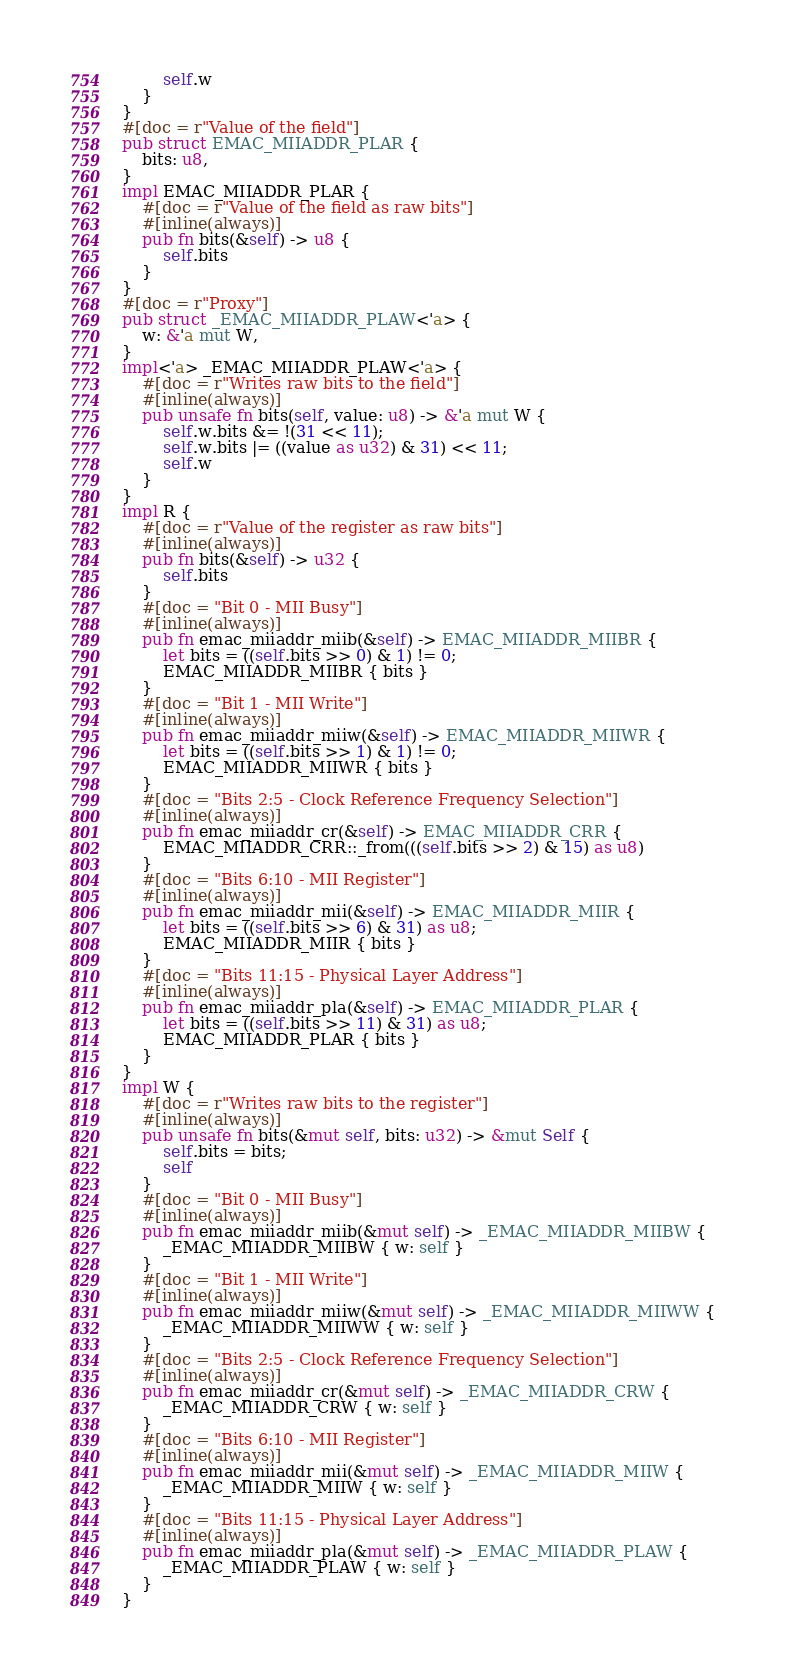Convert code to text. <code><loc_0><loc_0><loc_500><loc_500><_Rust_>        self.w
    }
}
#[doc = r"Value of the field"]
pub struct EMAC_MIIADDR_PLAR {
    bits: u8,
}
impl EMAC_MIIADDR_PLAR {
    #[doc = r"Value of the field as raw bits"]
    #[inline(always)]
    pub fn bits(&self) -> u8 {
        self.bits
    }
}
#[doc = r"Proxy"]
pub struct _EMAC_MIIADDR_PLAW<'a> {
    w: &'a mut W,
}
impl<'a> _EMAC_MIIADDR_PLAW<'a> {
    #[doc = r"Writes raw bits to the field"]
    #[inline(always)]
    pub unsafe fn bits(self, value: u8) -> &'a mut W {
        self.w.bits &= !(31 << 11);
        self.w.bits |= ((value as u32) & 31) << 11;
        self.w
    }
}
impl R {
    #[doc = r"Value of the register as raw bits"]
    #[inline(always)]
    pub fn bits(&self) -> u32 {
        self.bits
    }
    #[doc = "Bit 0 - MII Busy"]
    #[inline(always)]
    pub fn emac_miiaddr_miib(&self) -> EMAC_MIIADDR_MIIBR {
        let bits = ((self.bits >> 0) & 1) != 0;
        EMAC_MIIADDR_MIIBR { bits }
    }
    #[doc = "Bit 1 - MII Write"]
    #[inline(always)]
    pub fn emac_miiaddr_miiw(&self) -> EMAC_MIIADDR_MIIWR {
        let bits = ((self.bits >> 1) & 1) != 0;
        EMAC_MIIADDR_MIIWR { bits }
    }
    #[doc = "Bits 2:5 - Clock Reference Frequency Selection"]
    #[inline(always)]
    pub fn emac_miiaddr_cr(&self) -> EMAC_MIIADDR_CRR {
        EMAC_MIIADDR_CRR::_from(((self.bits >> 2) & 15) as u8)
    }
    #[doc = "Bits 6:10 - MII Register"]
    #[inline(always)]
    pub fn emac_miiaddr_mii(&self) -> EMAC_MIIADDR_MIIR {
        let bits = ((self.bits >> 6) & 31) as u8;
        EMAC_MIIADDR_MIIR { bits }
    }
    #[doc = "Bits 11:15 - Physical Layer Address"]
    #[inline(always)]
    pub fn emac_miiaddr_pla(&self) -> EMAC_MIIADDR_PLAR {
        let bits = ((self.bits >> 11) & 31) as u8;
        EMAC_MIIADDR_PLAR { bits }
    }
}
impl W {
    #[doc = r"Writes raw bits to the register"]
    #[inline(always)]
    pub unsafe fn bits(&mut self, bits: u32) -> &mut Self {
        self.bits = bits;
        self
    }
    #[doc = "Bit 0 - MII Busy"]
    #[inline(always)]
    pub fn emac_miiaddr_miib(&mut self) -> _EMAC_MIIADDR_MIIBW {
        _EMAC_MIIADDR_MIIBW { w: self }
    }
    #[doc = "Bit 1 - MII Write"]
    #[inline(always)]
    pub fn emac_miiaddr_miiw(&mut self) -> _EMAC_MIIADDR_MIIWW {
        _EMAC_MIIADDR_MIIWW { w: self }
    }
    #[doc = "Bits 2:5 - Clock Reference Frequency Selection"]
    #[inline(always)]
    pub fn emac_miiaddr_cr(&mut self) -> _EMAC_MIIADDR_CRW {
        _EMAC_MIIADDR_CRW { w: self }
    }
    #[doc = "Bits 6:10 - MII Register"]
    #[inline(always)]
    pub fn emac_miiaddr_mii(&mut self) -> _EMAC_MIIADDR_MIIW {
        _EMAC_MIIADDR_MIIW { w: self }
    }
    #[doc = "Bits 11:15 - Physical Layer Address"]
    #[inline(always)]
    pub fn emac_miiaddr_pla(&mut self) -> _EMAC_MIIADDR_PLAW {
        _EMAC_MIIADDR_PLAW { w: self }
    }
}
</code> 